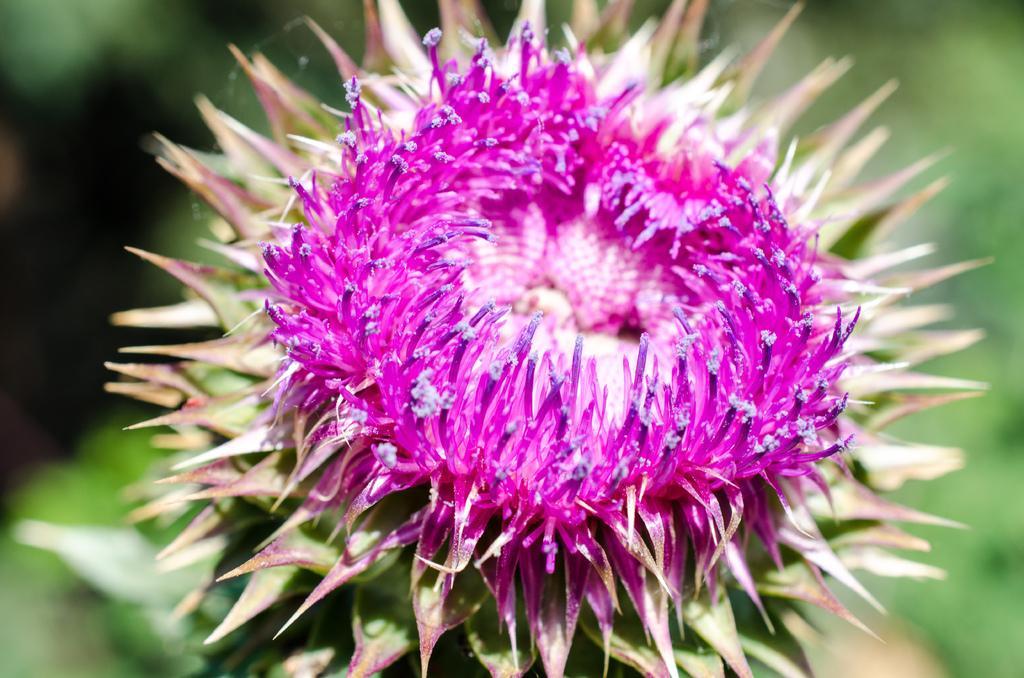How would you summarize this image in a sentence or two? In this picture we can see a flower. Behind the flower, there is a blurred background. 